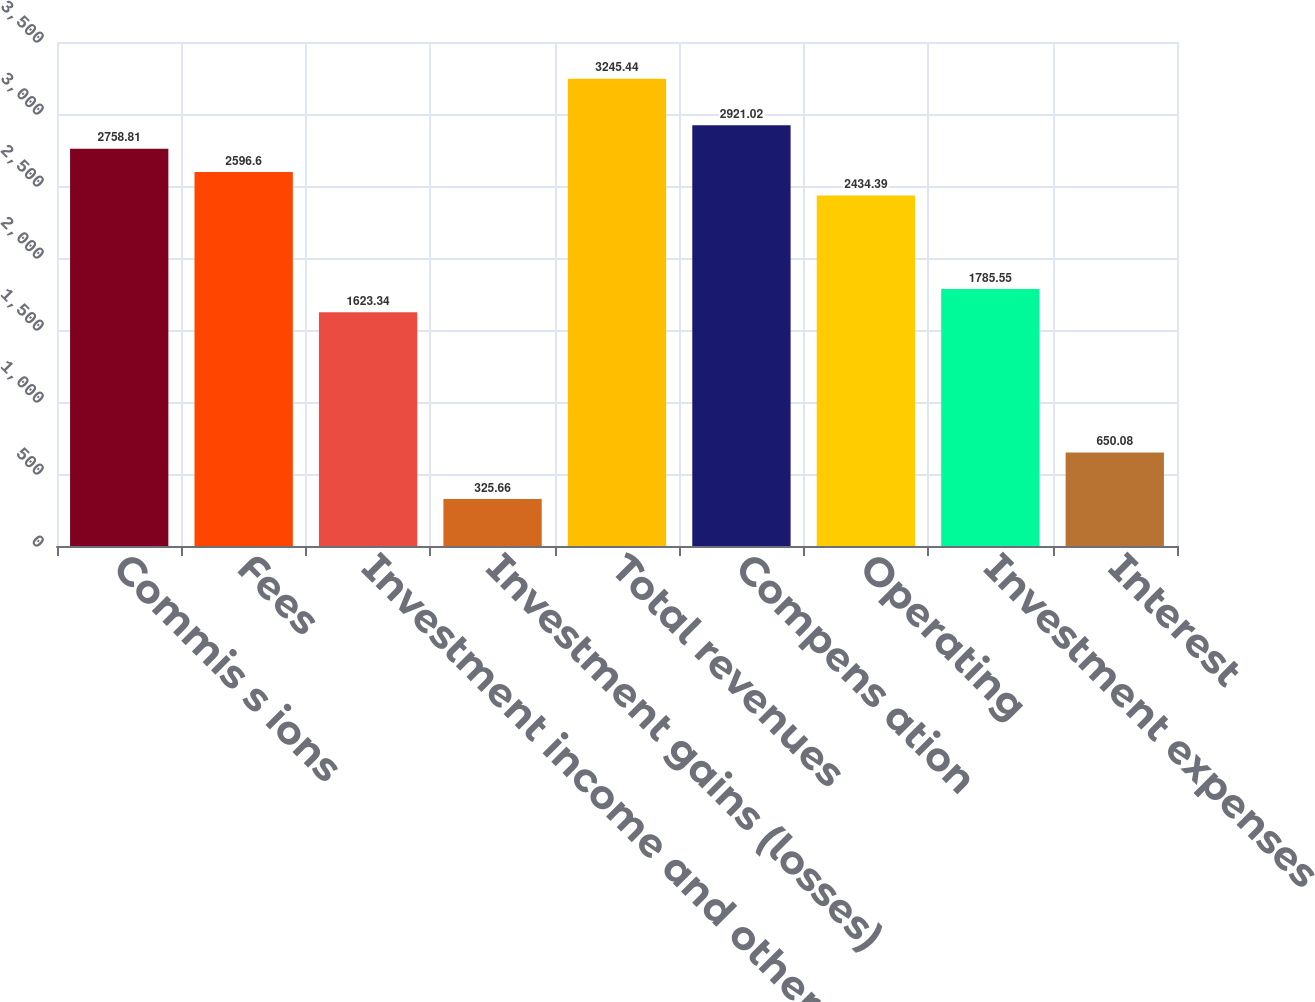Convert chart to OTSL. <chart><loc_0><loc_0><loc_500><loc_500><bar_chart><fcel>Commis s ions<fcel>Fees<fcel>Investment income and other -<fcel>Investment gains (losses)<fcel>Total revenues<fcel>Compens ation<fcel>Operating<fcel>Investment expenses<fcel>Interest<nl><fcel>2758.81<fcel>2596.6<fcel>1623.34<fcel>325.66<fcel>3245.44<fcel>2921.02<fcel>2434.39<fcel>1785.55<fcel>650.08<nl></chart> 